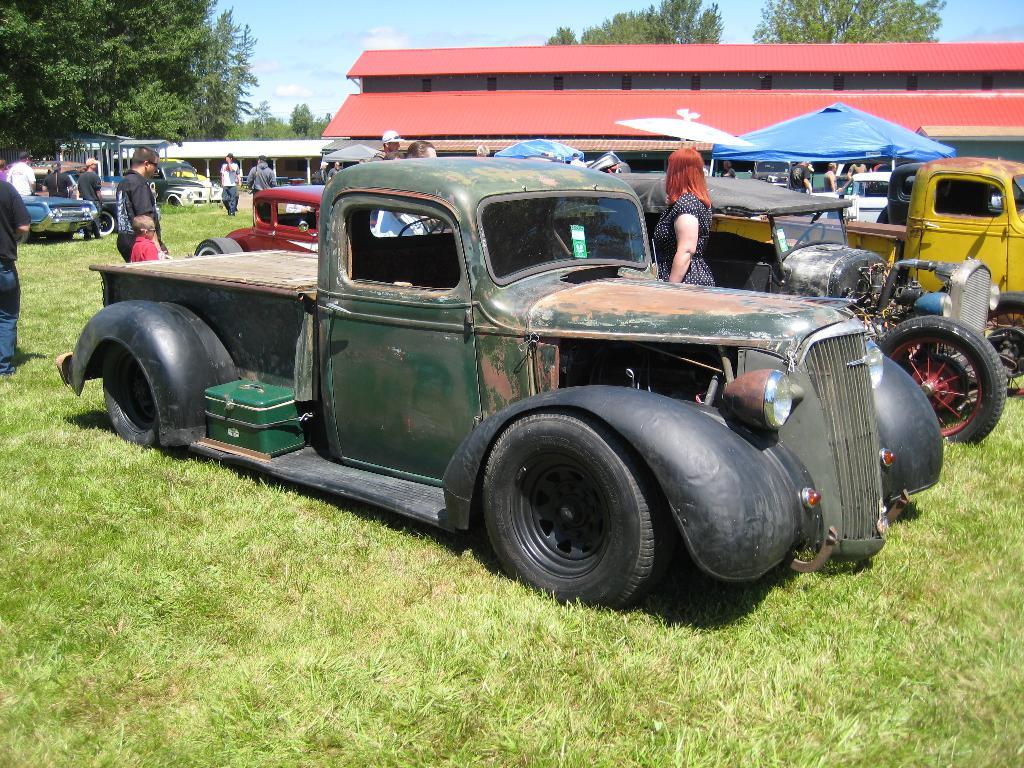What can be seen in the sky in the image? There is sky in the image. What type of structure is present in the image? There is a building in the image. What type of vegetation is visible in the image? There are trees in the image. What type of transportation is present in the image? There are vehicles in the image. Who or what is present in the image? There are people in the image. What type of ground surface is visible in the image? There is grass in the image. How long is the string attached to the holiday decoration in the image? There is no holiday decoration or string present in the image. What type of holiday is being celebrated in the image? There is no holiday being celebrated in the image. 